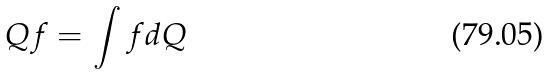Convert formula to latex. <formula><loc_0><loc_0><loc_500><loc_500>Q f = \int f d Q</formula> 